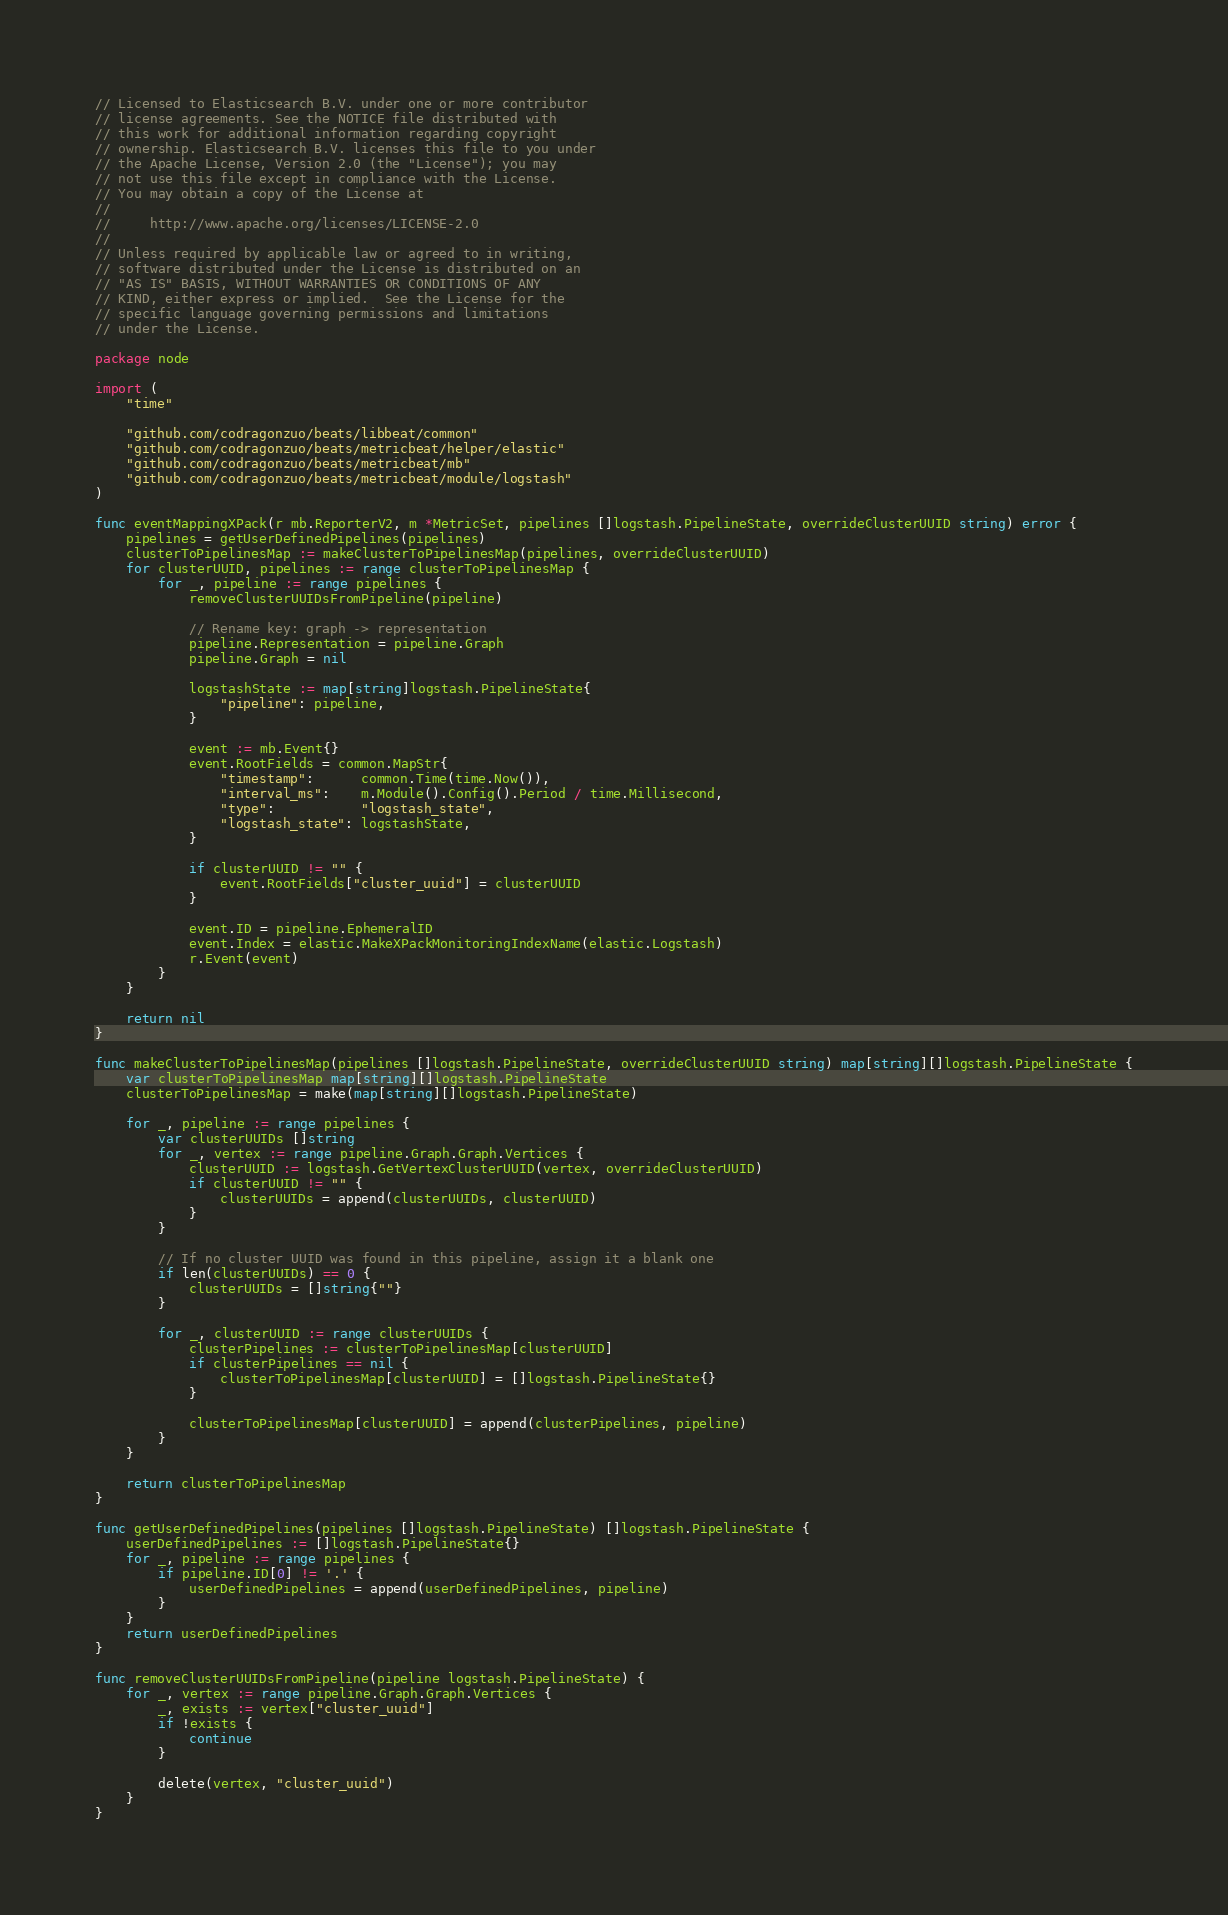<code> <loc_0><loc_0><loc_500><loc_500><_Go_>// Licensed to Elasticsearch B.V. under one or more contributor
// license agreements. See the NOTICE file distributed with
// this work for additional information regarding copyright
// ownership. Elasticsearch B.V. licenses this file to you under
// the Apache License, Version 2.0 (the "License"); you may
// not use this file except in compliance with the License.
// You may obtain a copy of the License at
//
//     http://www.apache.org/licenses/LICENSE-2.0
//
// Unless required by applicable law or agreed to in writing,
// software distributed under the License is distributed on an
// "AS IS" BASIS, WITHOUT WARRANTIES OR CONDITIONS OF ANY
// KIND, either express or implied.  See the License for the
// specific language governing permissions and limitations
// under the License.

package node

import (
	"time"

	"github.com/codragonzuo/beats/libbeat/common"
	"github.com/codragonzuo/beats/metricbeat/helper/elastic"
	"github.com/codragonzuo/beats/metricbeat/mb"
	"github.com/codragonzuo/beats/metricbeat/module/logstash"
)

func eventMappingXPack(r mb.ReporterV2, m *MetricSet, pipelines []logstash.PipelineState, overrideClusterUUID string) error {
	pipelines = getUserDefinedPipelines(pipelines)
	clusterToPipelinesMap := makeClusterToPipelinesMap(pipelines, overrideClusterUUID)
	for clusterUUID, pipelines := range clusterToPipelinesMap {
		for _, pipeline := range pipelines {
			removeClusterUUIDsFromPipeline(pipeline)

			// Rename key: graph -> representation
			pipeline.Representation = pipeline.Graph
			pipeline.Graph = nil

			logstashState := map[string]logstash.PipelineState{
				"pipeline": pipeline,
			}

			event := mb.Event{}
			event.RootFields = common.MapStr{
				"timestamp":      common.Time(time.Now()),
				"interval_ms":    m.Module().Config().Period / time.Millisecond,
				"type":           "logstash_state",
				"logstash_state": logstashState,
			}

			if clusterUUID != "" {
				event.RootFields["cluster_uuid"] = clusterUUID
			}

			event.ID = pipeline.EphemeralID
			event.Index = elastic.MakeXPackMonitoringIndexName(elastic.Logstash)
			r.Event(event)
		}
	}

	return nil
}

func makeClusterToPipelinesMap(pipelines []logstash.PipelineState, overrideClusterUUID string) map[string][]logstash.PipelineState {
	var clusterToPipelinesMap map[string][]logstash.PipelineState
	clusterToPipelinesMap = make(map[string][]logstash.PipelineState)

	for _, pipeline := range pipelines {
		var clusterUUIDs []string
		for _, vertex := range pipeline.Graph.Graph.Vertices {
			clusterUUID := logstash.GetVertexClusterUUID(vertex, overrideClusterUUID)
			if clusterUUID != "" {
				clusterUUIDs = append(clusterUUIDs, clusterUUID)
			}
		}

		// If no cluster UUID was found in this pipeline, assign it a blank one
		if len(clusterUUIDs) == 0 {
			clusterUUIDs = []string{""}
		}

		for _, clusterUUID := range clusterUUIDs {
			clusterPipelines := clusterToPipelinesMap[clusterUUID]
			if clusterPipelines == nil {
				clusterToPipelinesMap[clusterUUID] = []logstash.PipelineState{}
			}

			clusterToPipelinesMap[clusterUUID] = append(clusterPipelines, pipeline)
		}
	}

	return clusterToPipelinesMap
}

func getUserDefinedPipelines(pipelines []logstash.PipelineState) []logstash.PipelineState {
	userDefinedPipelines := []logstash.PipelineState{}
	for _, pipeline := range pipelines {
		if pipeline.ID[0] != '.' {
			userDefinedPipelines = append(userDefinedPipelines, pipeline)
		}
	}
	return userDefinedPipelines
}

func removeClusterUUIDsFromPipeline(pipeline logstash.PipelineState) {
	for _, vertex := range pipeline.Graph.Graph.Vertices {
		_, exists := vertex["cluster_uuid"]
		if !exists {
			continue
		}

		delete(vertex, "cluster_uuid")
	}
}
</code> 